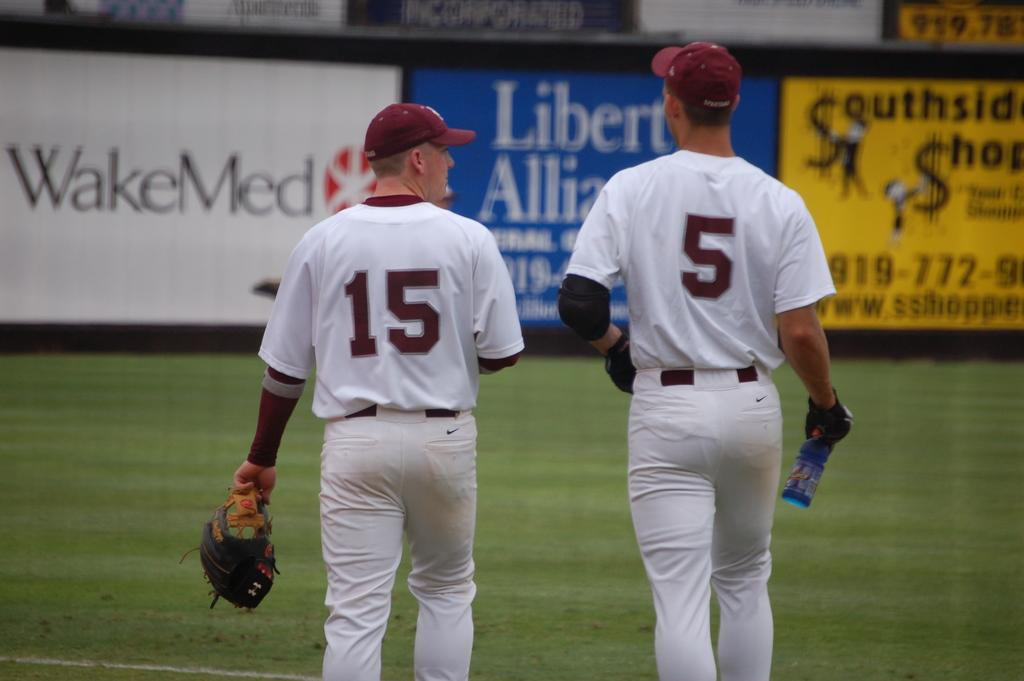<image>
Relay a brief, clear account of the picture shown. Two baseball players wearing white uniform and red cap walking on the field. 